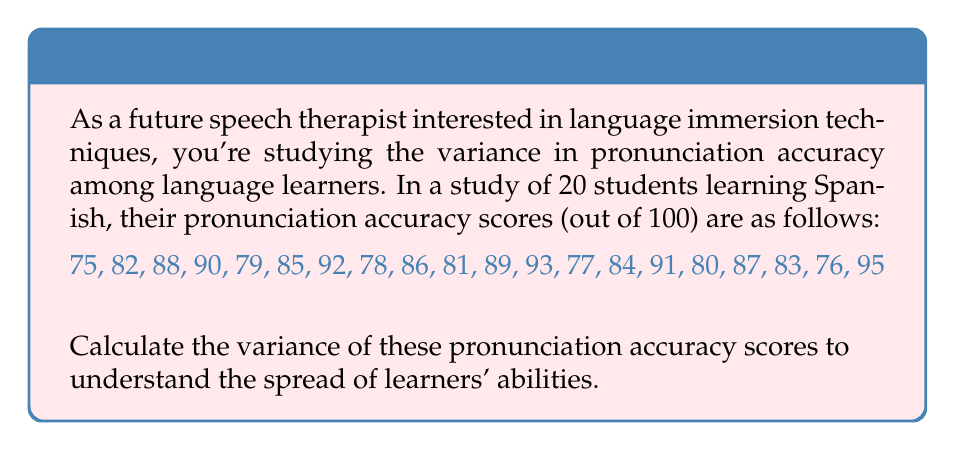Solve this math problem. To calculate the variance, we'll follow these steps:

1. Calculate the mean ($\mu$) of the scores:
   $$\mu = \frac{\sum_{i=1}^{n} x_i}{n} = \frac{1671}{20} = 83.55$$

2. Calculate the squared differences from the mean:
   $$(75 - 83.55)^2, (82 - 83.55)^2, ..., (95 - 83.55)^2$$

3. Sum the squared differences:
   $$\sum_{i=1}^{n} (x_i - \mu)^2 = 1288.95$$

4. Divide by $(n-1)$ to get the variance:
   $$\text{Variance} = \frac{\sum_{i=1}^{n} (x_i - \mu)^2}{n-1} = \frac{1288.95}{19} = 67.84$$

The variance formula is:
$$\sigma^2 = \frac{\sum_{i=1}^{n} (x_i - \mu)^2}{n-1}$$

Where:
$\sigma^2$ is the variance
$x_i$ are the individual values
$\mu$ is the mean
$n$ is the number of values
Answer: 67.84 